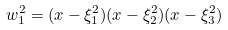Convert formula to latex. <formula><loc_0><loc_0><loc_500><loc_500>w _ { 1 } ^ { 2 } = ( x - \xi _ { 1 } ^ { 2 } ) ( x - \xi _ { 2 } ^ { 2 } ) ( x - \xi _ { 3 } ^ { 2 } )</formula> 